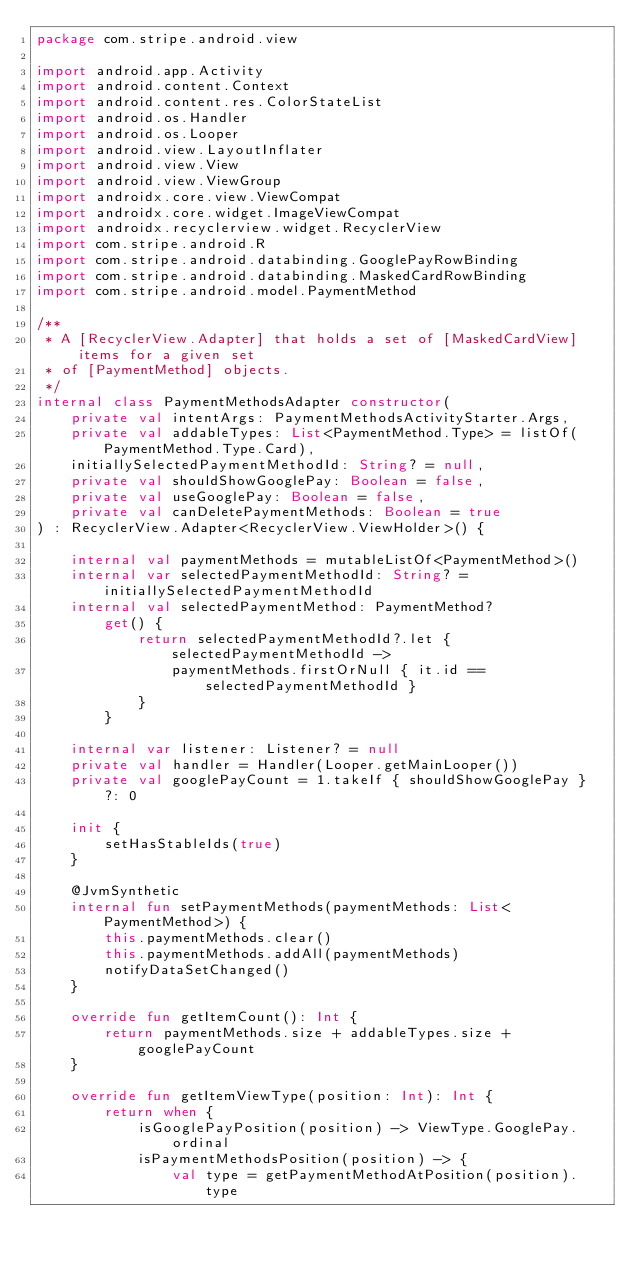<code> <loc_0><loc_0><loc_500><loc_500><_Kotlin_>package com.stripe.android.view

import android.app.Activity
import android.content.Context
import android.content.res.ColorStateList
import android.os.Handler
import android.os.Looper
import android.view.LayoutInflater
import android.view.View
import android.view.ViewGroup
import androidx.core.view.ViewCompat
import androidx.core.widget.ImageViewCompat
import androidx.recyclerview.widget.RecyclerView
import com.stripe.android.R
import com.stripe.android.databinding.GooglePayRowBinding
import com.stripe.android.databinding.MaskedCardRowBinding
import com.stripe.android.model.PaymentMethod

/**
 * A [RecyclerView.Adapter] that holds a set of [MaskedCardView] items for a given set
 * of [PaymentMethod] objects.
 */
internal class PaymentMethodsAdapter constructor(
    private val intentArgs: PaymentMethodsActivityStarter.Args,
    private val addableTypes: List<PaymentMethod.Type> = listOf(PaymentMethod.Type.Card),
    initiallySelectedPaymentMethodId: String? = null,
    private val shouldShowGooglePay: Boolean = false,
    private val useGooglePay: Boolean = false,
    private val canDeletePaymentMethods: Boolean = true
) : RecyclerView.Adapter<RecyclerView.ViewHolder>() {

    internal val paymentMethods = mutableListOf<PaymentMethod>()
    internal var selectedPaymentMethodId: String? = initiallySelectedPaymentMethodId
    internal val selectedPaymentMethod: PaymentMethod?
        get() {
            return selectedPaymentMethodId?.let { selectedPaymentMethodId ->
                paymentMethods.firstOrNull { it.id == selectedPaymentMethodId }
            }
        }

    internal var listener: Listener? = null
    private val handler = Handler(Looper.getMainLooper())
    private val googlePayCount = 1.takeIf { shouldShowGooglePay } ?: 0

    init {
        setHasStableIds(true)
    }

    @JvmSynthetic
    internal fun setPaymentMethods(paymentMethods: List<PaymentMethod>) {
        this.paymentMethods.clear()
        this.paymentMethods.addAll(paymentMethods)
        notifyDataSetChanged()
    }

    override fun getItemCount(): Int {
        return paymentMethods.size + addableTypes.size + googlePayCount
    }

    override fun getItemViewType(position: Int): Int {
        return when {
            isGooglePayPosition(position) -> ViewType.GooglePay.ordinal
            isPaymentMethodsPosition(position) -> {
                val type = getPaymentMethodAtPosition(position).type</code> 